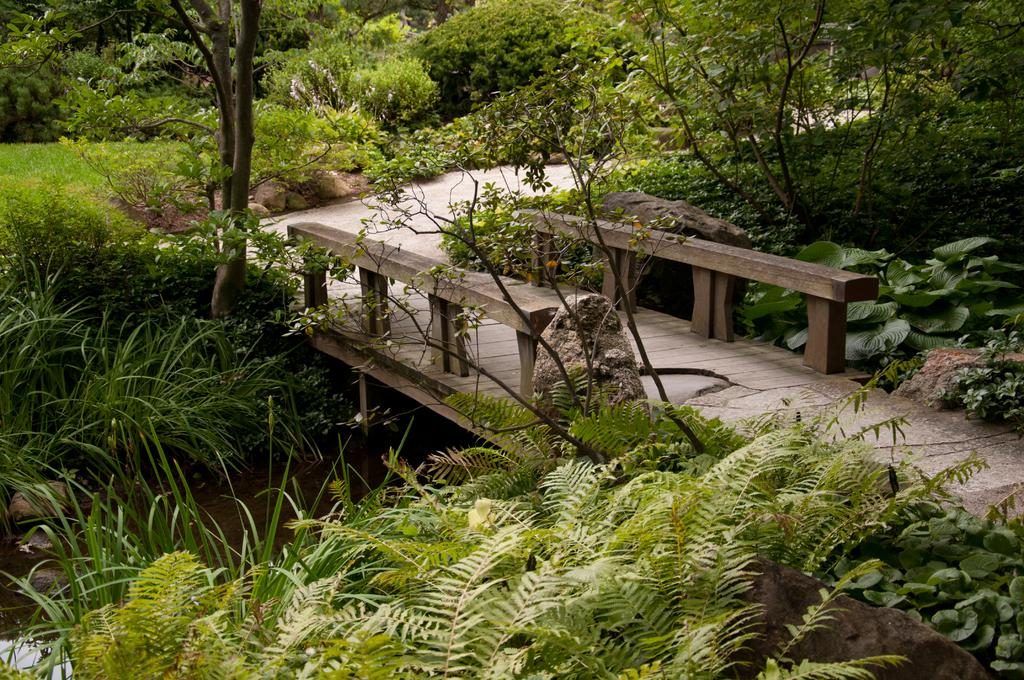What is the primary element visible in the image? There is water in the image. What types of vegetation can be seen in the image? There are plants and trees in the image. What time does the clock show in the image? There is no clock present in the image. What type of transportation can be seen at the station in the image? There is no station or transportation present in the image. 